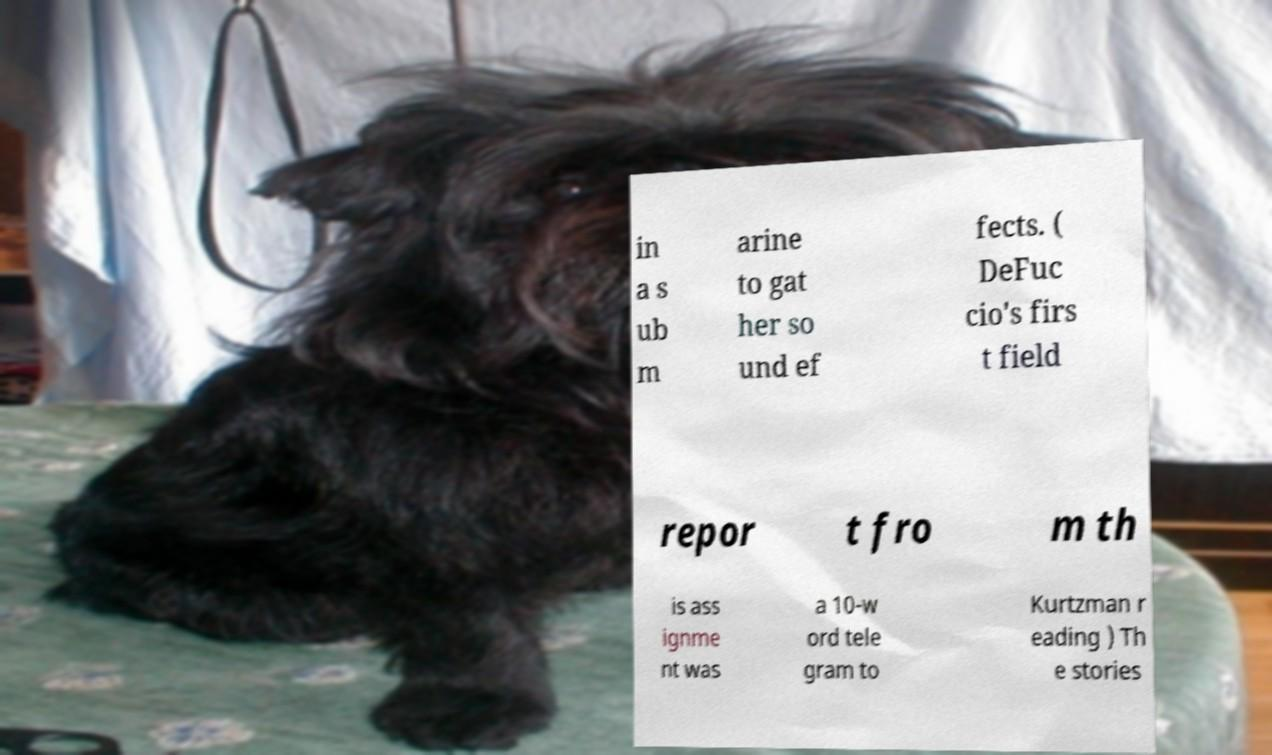What messages or text are displayed in this image? I need them in a readable, typed format. in a s ub m arine to gat her so und ef fects. ( DeFuc cio's firs t field repor t fro m th is ass ignme nt was a 10-w ord tele gram to Kurtzman r eading ) Th e stories 